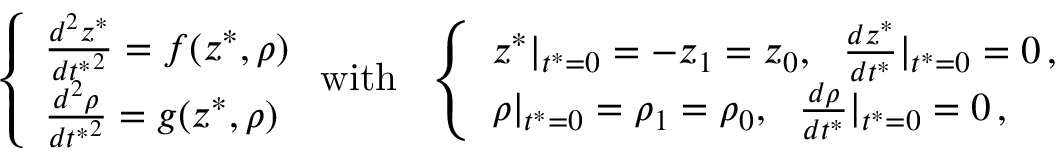<formula> <loc_0><loc_0><loc_500><loc_500>\left \{ \begin{array} { l l } { \frac { d ^ { 2 } z ^ { * } } { { d t ^ { * } } ^ { 2 } } = f ( z ^ { * } , \rho ) } \\ { \frac { d ^ { 2 } \rho } { { d t ^ { * } } ^ { 2 } } = g ( z ^ { * } , \rho ) } \end{array} w i t h \quad l e f t \{ \begin{array} { l l } { z ^ { * } | _ { t ^ { * } = 0 } = - z _ { 1 } = z _ { 0 } , \quad f r a c { d z ^ { * } } { d t ^ { * } } | _ { t ^ { * } = 0 } = 0 \, , } \\ { \rho | _ { t ^ { * } = 0 } = \rho _ { 1 } = \rho _ { 0 } , \quad f r a c { d \rho } { d t ^ { * } } | _ { t ^ { * } = 0 } = 0 \, , } \end{array}</formula> 